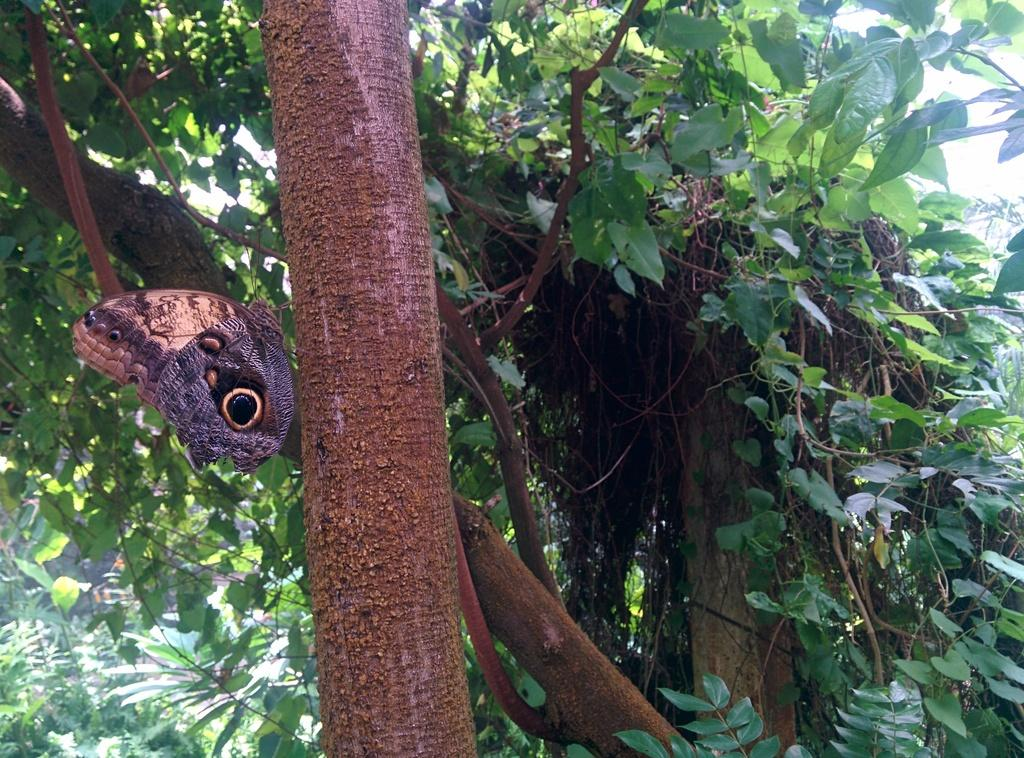What is on the tree on the left side of the image? There is a butterfly on a tree on the left side of the image. What can be seen in the background of the image? There are trees, plants, and clouds in the sky in the background of the image. What type of metal is the butterfly made of in the image? The butterfly in the image is not made of metal; it is a living creature. 